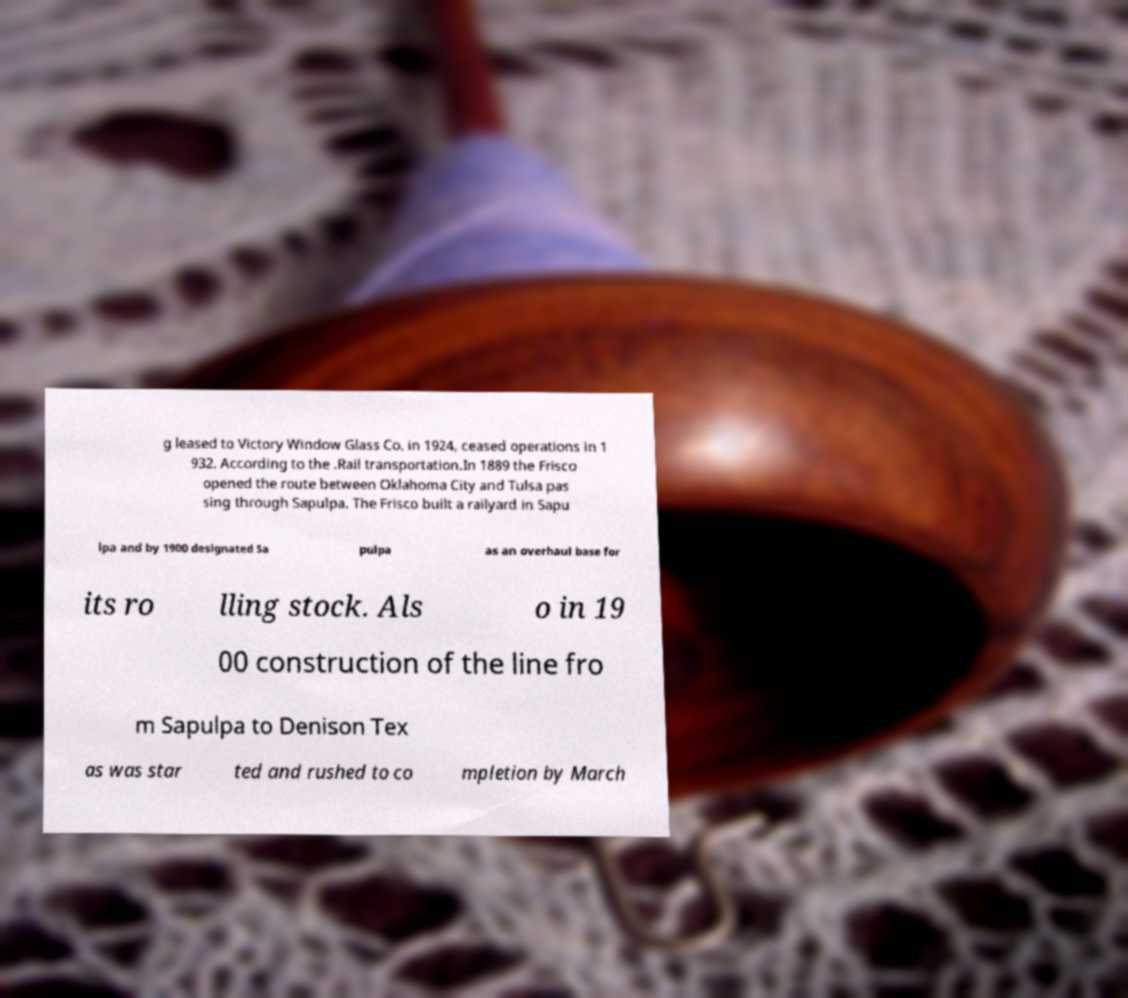Could you assist in decoding the text presented in this image and type it out clearly? g leased to Victory Window Glass Co. in 1924, ceased operations in 1 932. According to the .Rail transportation.In 1889 the Frisco opened the route between Oklahoma City and Tulsa pas sing through Sapulpa. The Frisco built a railyard in Sapu lpa and by 1900 designated Sa pulpa as an overhaul base for its ro lling stock. Als o in 19 00 construction of the line fro m Sapulpa to Denison Tex as was star ted and rushed to co mpletion by March 